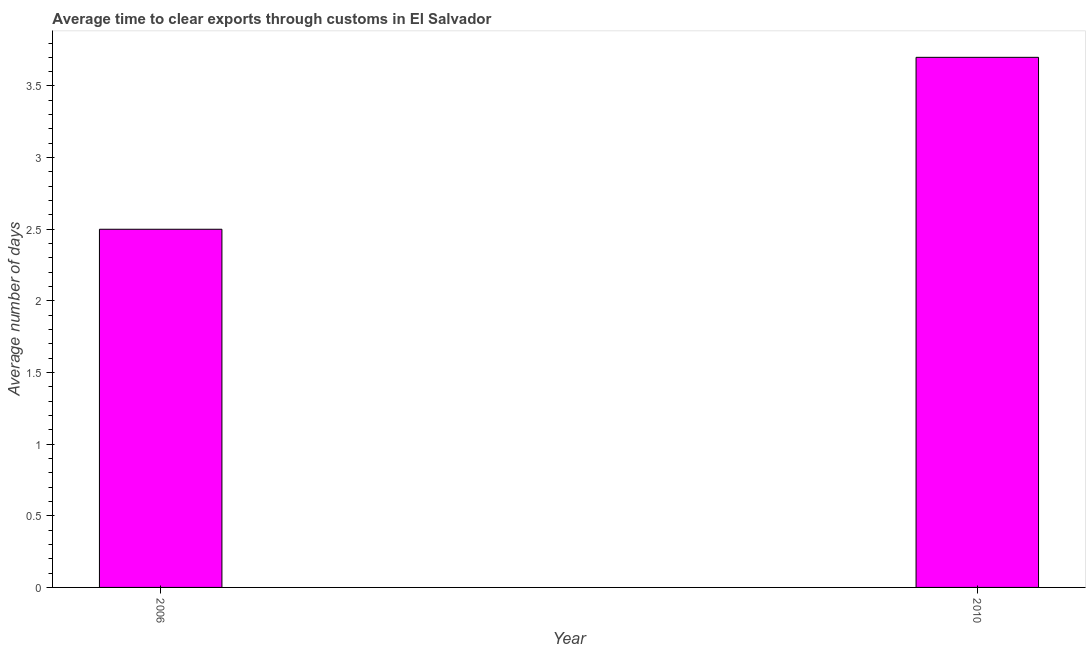What is the title of the graph?
Provide a succinct answer. Average time to clear exports through customs in El Salvador. What is the label or title of the Y-axis?
Offer a very short reply. Average number of days. What is the sum of the time to clear exports through customs?
Make the answer very short. 6.2. What is the median time to clear exports through customs?
Provide a short and direct response. 3.1. What is the ratio of the time to clear exports through customs in 2006 to that in 2010?
Offer a terse response. 0.68. Is the time to clear exports through customs in 2006 less than that in 2010?
Make the answer very short. Yes. In how many years, is the time to clear exports through customs greater than the average time to clear exports through customs taken over all years?
Ensure brevity in your answer.  1. Are all the bars in the graph horizontal?
Offer a very short reply. No. What is the difference between two consecutive major ticks on the Y-axis?
Offer a very short reply. 0.5. Are the values on the major ticks of Y-axis written in scientific E-notation?
Keep it short and to the point. No. What is the ratio of the Average number of days in 2006 to that in 2010?
Your response must be concise. 0.68. 